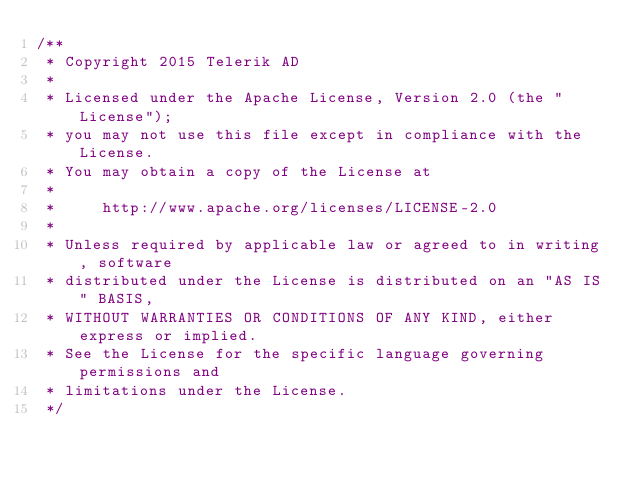Convert code to text. <code><loc_0><loc_0><loc_500><loc_500><_JavaScript_>/**
 * Copyright 2015 Telerik AD
 *
 * Licensed under the Apache License, Version 2.0 (the "License");
 * you may not use this file except in compliance with the License.
 * You may obtain a copy of the License at
 *
 *     http://www.apache.org/licenses/LICENSE-2.0
 *
 * Unless required by applicable law or agreed to in writing, software
 * distributed under the License is distributed on an "AS IS" BASIS,
 * WITHOUT WARRANTIES OR CONDITIONS OF ANY KIND, either express or implied.
 * See the License for the specific language governing permissions and
 * limitations under the License.
 */</code> 